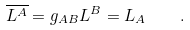<formula> <loc_0><loc_0><loc_500><loc_500>\overline { L ^ { A } } = g _ { A B } L ^ { B } = L _ { A } \quad .</formula> 